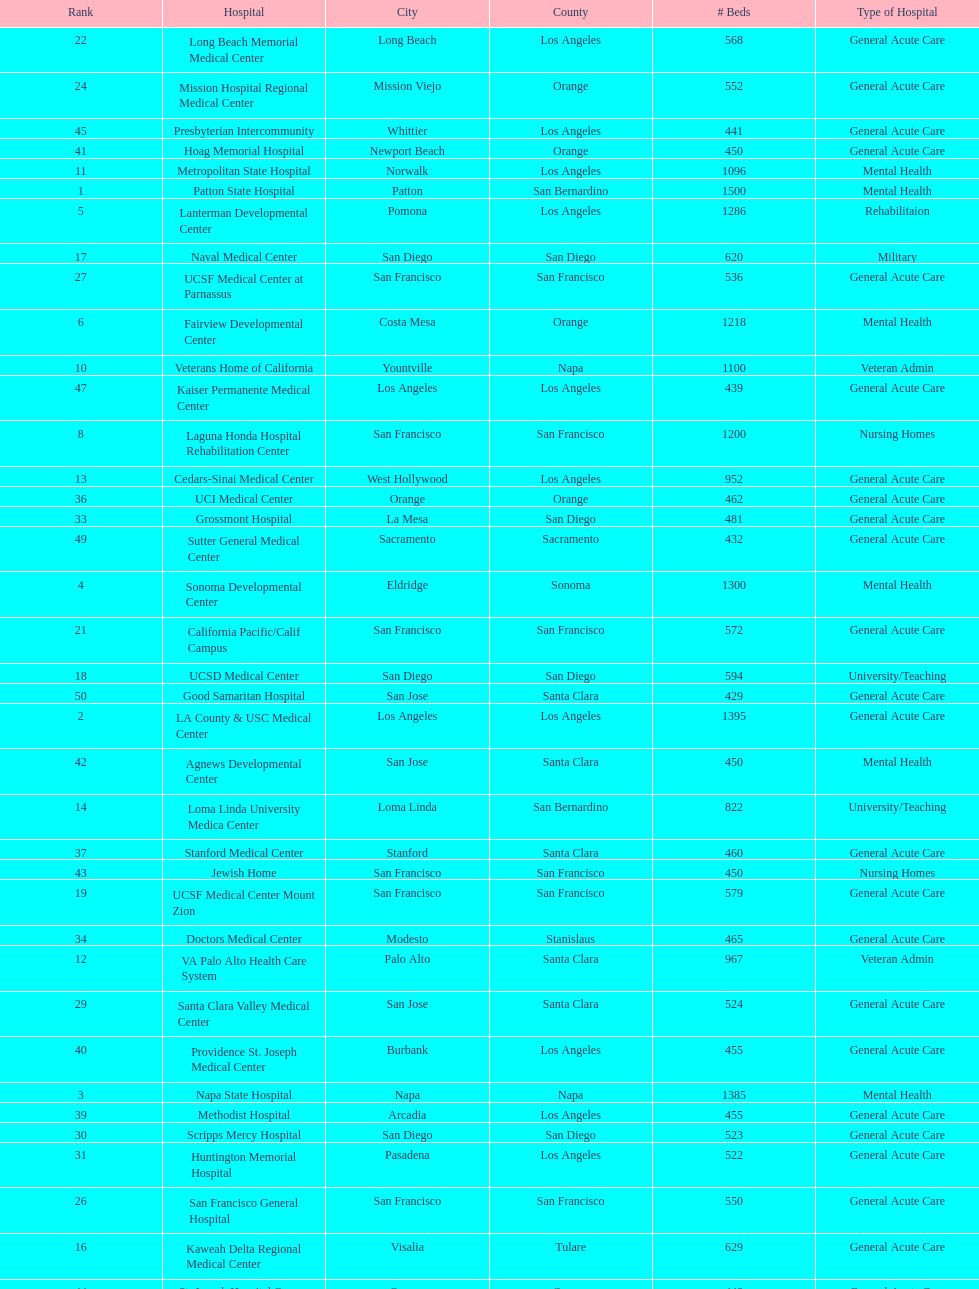Can you parse all the data within this table? {'header': ['Rank', 'Hospital', 'City', 'County', '# Beds', 'Type of Hospital'], 'rows': [['22', 'Long Beach Memorial Medical Center', 'Long Beach', 'Los Angeles', '568', 'General Acute Care'], ['24', 'Mission Hospital Regional Medical Center', 'Mission Viejo', 'Orange', '552', 'General Acute Care'], ['45', 'Presbyterian Intercommunity', 'Whittier', 'Los Angeles', '441', 'General Acute Care'], ['41', 'Hoag Memorial Hospital', 'Newport Beach', 'Orange', '450', 'General Acute Care'], ['11', 'Metropolitan State Hospital', 'Norwalk', 'Los Angeles', '1096', 'Mental Health'], ['1', 'Patton State Hospital', 'Patton', 'San Bernardino', '1500', 'Mental Health'], ['5', 'Lanterman Developmental Center', 'Pomona', 'Los Angeles', '1286', 'Rehabilitaion'], ['17', 'Naval Medical Center', 'San Diego', 'San Diego', '620', 'Military'], ['27', 'UCSF Medical Center at Parnassus', 'San Francisco', 'San Francisco', '536', 'General Acute Care'], ['6', 'Fairview Developmental Center', 'Costa Mesa', 'Orange', '1218', 'Mental Health'], ['10', 'Veterans Home of California', 'Yountville', 'Napa', '1100', 'Veteran Admin'], ['47', 'Kaiser Permanente Medical Center', 'Los Angeles', 'Los Angeles', '439', 'General Acute Care'], ['8', 'Laguna Honda Hospital Rehabilitation Center', 'San Francisco', 'San Francisco', '1200', 'Nursing Homes'], ['13', 'Cedars-Sinai Medical Center', 'West Hollywood', 'Los Angeles', '952', 'General Acute Care'], ['36', 'UCI Medical Center', 'Orange', 'Orange', '462', 'General Acute Care'], ['33', 'Grossmont Hospital', 'La Mesa', 'San Diego', '481', 'General Acute Care'], ['49', 'Sutter General Medical Center', 'Sacramento', 'Sacramento', '432', 'General Acute Care'], ['4', 'Sonoma Developmental Center', 'Eldridge', 'Sonoma', '1300', 'Mental Health'], ['21', 'California Pacific/Calif Campus', 'San Francisco', 'San Francisco', '572', 'General Acute Care'], ['18', 'UCSD Medical Center', 'San Diego', 'San Diego', '594', 'University/Teaching'], ['50', 'Good Samaritan Hospital', 'San Jose', 'Santa Clara', '429', 'General Acute Care'], ['2', 'LA County & USC Medical Center', 'Los Angeles', 'Los Angeles', '1395', 'General Acute Care'], ['42', 'Agnews Developmental Center', 'San Jose', 'Santa Clara', '450', 'Mental Health'], ['14', 'Loma Linda University Medica Center', 'Loma Linda', 'San Bernardino', '822', 'University/Teaching'], ['37', 'Stanford Medical Center', 'Stanford', 'Santa Clara', '460', 'General Acute Care'], ['43', 'Jewish Home', 'San Francisco', 'San Francisco', '450', 'Nursing Homes'], ['19', 'UCSF Medical Center Mount Zion', 'San Francisco', 'San Francisco', '579', 'General Acute Care'], ['34', 'Doctors Medical Center', 'Modesto', 'Stanislaus', '465', 'General Acute Care'], ['12', 'VA Palo Alto Health Care System', 'Palo Alto', 'Santa Clara', '967', 'Veteran Admin'], ['29', 'Santa Clara Valley Medical Center', 'San Jose', 'Santa Clara', '524', 'General Acute Care'], ['40', 'Providence St. Joseph Medical Center', 'Burbank', 'Los Angeles', '455', 'General Acute Care'], ['3', 'Napa State Hospital', 'Napa', 'Napa', '1385', 'Mental Health'], ['39', 'Methodist Hospital', 'Arcadia', 'Los Angeles', '455', 'General Acute Care'], ['30', 'Scripps Mercy Hospital', 'San Diego', 'San Diego', '523', 'General Acute Care'], ['31', 'Huntington Memorial Hospital', 'Pasadena', 'Los Angeles', '522', 'General Acute Care'], ['26', 'San Francisco General Hospital', 'San Francisco', 'San Francisco', '550', 'General Acute Care'], ['16', 'Kaweah Delta Regional Medical Center', 'Visalia', 'Tulare', '629', 'General Acute Care'], ['44', 'St. Joseph Hospital Orange', 'Orange', 'Orange', '448', 'General Acute Care'], ['15', 'UCLA Medical Center', 'Los Angeles', 'Los Angeles', '668', 'General Acute Care'], ['32', 'Adventist Medical Center', 'Glendale', 'Los Angeles', '508', 'General Acute Care'], ['7', 'Porterville Developmental Center', 'Porterville', 'Tulare', '1210', 'Mental Health'], ['25', 'Alta Bates Summit Medical Center', 'Berkeley', 'Alameda', '551', 'General Acute Care'], ['9', 'Atascadero State Hospital', 'Atascadero', 'San Luis Obispo', '1200', 'Mental Health'], ['48', 'Pomona Valley Hospital Medical Center', 'Pomona', 'Los Angeles', '436', 'General Acute Care'], ['28', 'Alta Bates Summit Medical Center', 'Oakland', 'Alameda', '534', 'General Acute Care'], ['46', 'Kaiser Permanente Medical Center', 'Fontana', 'San Bernardino', '440', 'General Acute Care'], ['50', 'St. Mary Medical Center', 'San Francisco', 'San Francisco', '430', 'General Acute Care'], ['35', 'St. Bernardine Medical Center', 'San Bernardino', 'San Bernardino', '463', 'General Acute Care'], ['20', 'UCD Medical Center', 'Sacramento', 'Sacramento', '577', 'University/Teaching'], ['38', 'Community Regional Medical Center', 'Fresno', 'Fresno', '457', 'General Acute Care'], ['23', 'Harbor UCLA Medical Center', 'Torrance', 'Los Angeles', '553', 'General Acute Care']]} Does patton state hospital in the city of patton in san bernardino county have more mental health hospital beds than atascadero state hospital in atascadero, san luis obispo county? Yes. 